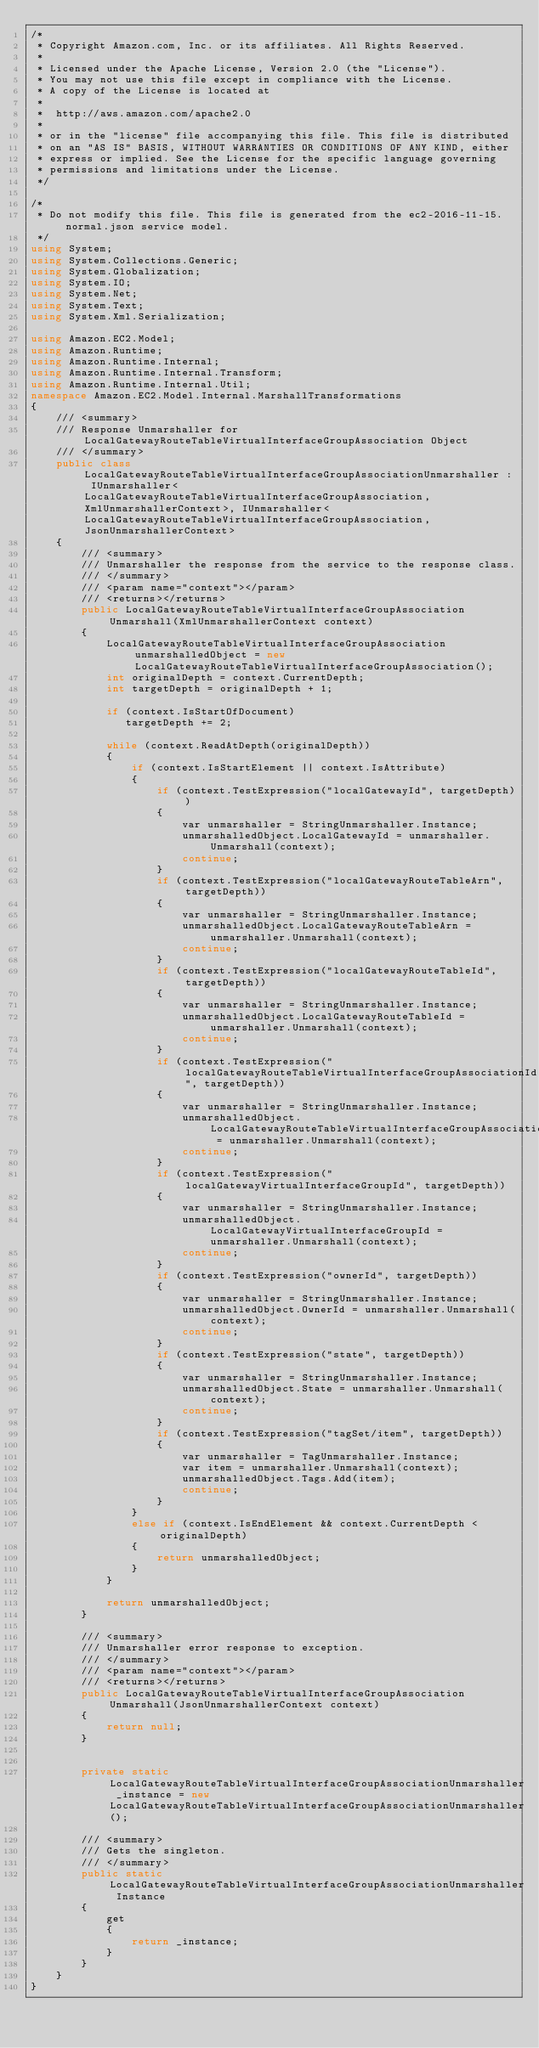<code> <loc_0><loc_0><loc_500><loc_500><_C#_>/*
 * Copyright Amazon.com, Inc. or its affiliates. All Rights Reserved.
 * 
 * Licensed under the Apache License, Version 2.0 (the "License").
 * You may not use this file except in compliance with the License.
 * A copy of the License is located at
 * 
 *  http://aws.amazon.com/apache2.0
 * 
 * or in the "license" file accompanying this file. This file is distributed
 * on an "AS IS" BASIS, WITHOUT WARRANTIES OR CONDITIONS OF ANY KIND, either
 * express or implied. See the License for the specific language governing
 * permissions and limitations under the License.
 */

/*
 * Do not modify this file. This file is generated from the ec2-2016-11-15.normal.json service model.
 */
using System;
using System.Collections.Generic;
using System.Globalization;
using System.IO;
using System.Net;
using System.Text;
using System.Xml.Serialization;

using Amazon.EC2.Model;
using Amazon.Runtime;
using Amazon.Runtime.Internal;
using Amazon.Runtime.Internal.Transform;
using Amazon.Runtime.Internal.Util;
namespace Amazon.EC2.Model.Internal.MarshallTransformations
{
    /// <summary>
    /// Response Unmarshaller for LocalGatewayRouteTableVirtualInterfaceGroupAssociation Object
    /// </summary>  
    public class LocalGatewayRouteTableVirtualInterfaceGroupAssociationUnmarshaller : IUnmarshaller<LocalGatewayRouteTableVirtualInterfaceGroupAssociation, XmlUnmarshallerContext>, IUnmarshaller<LocalGatewayRouteTableVirtualInterfaceGroupAssociation, JsonUnmarshallerContext>
    {
        /// <summary>
        /// Unmarshaller the response from the service to the response class.
        /// </summary>  
        /// <param name="context"></param>
        /// <returns></returns>
        public LocalGatewayRouteTableVirtualInterfaceGroupAssociation Unmarshall(XmlUnmarshallerContext context)
        {
            LocalGatewayRouteTableVirtualInterfaceGroupAssociation unmarshalledObject = new LocalGatewayRouteTableVirtualInterfaceGroupAssociation();
            int originalDepth = context.CurrentDepth;
            int targetDepth = originalDepth + 1;
            
            if (context.IsStartOfDocument) 
               targetDepth += 2;
            
            while (context.ReadAtDepth(originalDepth))
            {
                if (context.IsStartElement || context.IsAttribute)
                {
                    if (context.TestExpression("localGatewayId", targetDepth))
                    {
                        var unmarshaller = StringUnmarshaller.Instance;
                        unmarshalledObject.LocalGatewayId = unmarshaller.Unmarshall(context);
                        continue;
                    }
                    if (context.TestExpression("localGatewayRouteTableArn", targetDepth))
                    {
                        var unmarshaller = StringUnmarshaller.Instance;
                        unmarshalledObject.LocalGatewayRouteTableArn = unmarshaller.Unmarshall(context);
                        continue;
                    }
                    if (context.TestExpression("localGatewayRouteTableId", targetDepth))
                    {
                        var unmarshaller = StringUnmarshaller.Instance;
                        unmarshalledObject.LocalGatewayRouteTableId = unmarshaller.Unmarshall(context);
                        continue;
                    }
                    if (context.TestExpression("localGatewayRouteTableVirtualInterfaceGroupAssociationId", targetDepth))
                    {
                        var unmarshaller = StringUnmarshaller.Instance;
                        unmarshalledObject.LocalGatewayRouteTableVirtualInterfaceGroupAssociationId = unmarshaller.Unmarshall(context);
                        continue;
                    }
                    if (context.TestExpression("localGatewayVirtualInterfaceGroupId", targetDepth))
                    {
                        var unmarshaller = StringUnmarshaller.Instance;
                        unmarshalledObject.LocalGatewayVirtualInterfaceGroupId = unmarshaller.Unmarshall(context);
                        continue;
                    }
                    if (context.TestExpression("ownerId", targetDepth))
                    {
                        var unmarshaller = StringUnmarshaller.Instance;
                        unmarshalledObject.OwnerId = unmarshaller.Unmarshall(context);
                        continue;
                    }
                    if (context.TestExpression("state", targetDepth))
                    {
                        var unmarshaller = StringUnmarshaller.Instance;
                        unmarshalledObject.State = unmarshaller.Unmarshall(context);
                        continue;
                    }
                    if (context.TestExpression("tagSet/item", targetDepth))
                    {
                        var unmarshaller = TagUnmarshaller.Instance;
                        var item = unmarshaller.Unmarshall(context);
                        unmarshalledObject.Tags.Add(item);
                        continue;
                    }
                }
                else if (context.IsEndElement && context.CurrentDepth < originalDepth)
                {
                    return unmarshalledObject;
                }
            }

            return unmarshalledObject;
        }

        /// <summary>
        /// Unmarshaller error response to exception.
        /// </summary>  
        /// <param name="context"></param>
        /// <returns></returns>
        public LocalGatewayRouteTableVirtualInterfaceGroupAssociation Unmarshall(JsonUnmarshallerContext context)
        {
            return null;
        }


        private static LocalGatewayRouteTableVirtualInterfaceGroupAssociationUnmarshaller _instance = new LocalGatewayRouteTableVirtualInterfaceGroupAssociationUnmarshaller();        

        /// <summary>
        /// Gets the singleton.
        /// </summary>  
        public static LocalGatewayRouteTableVirtualInterfaceGroupAssociationUnmarshaller Instance
        {
            get
            {
                return _instance;
            }
        }
    }
}</code> 